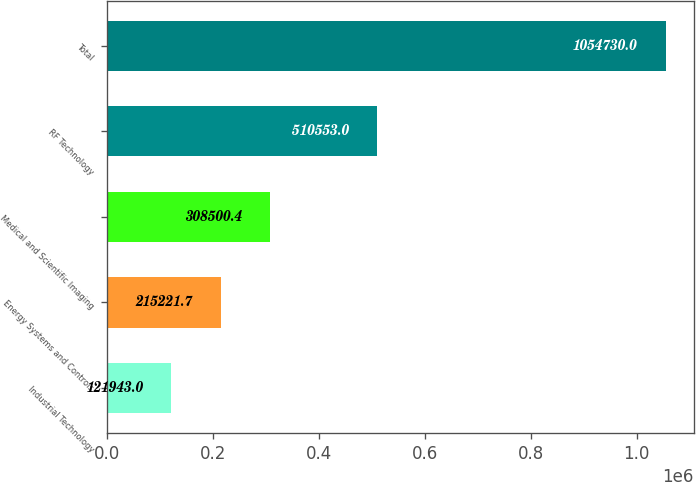Convert chart to OTSL. <chart><loc_0><loc_0><loc_500><loc_500><bar_chart><fcel>Industrial Technology<fcel>Energy Systems and Controls<fcel>Medical and Scientific Imaging<fcel>RF Technology<fcel>Total<nl><fcel>121943<fcel>215222<fcel>308500<fcel>510553<fcel>1.05473e+06<nl></chart> 